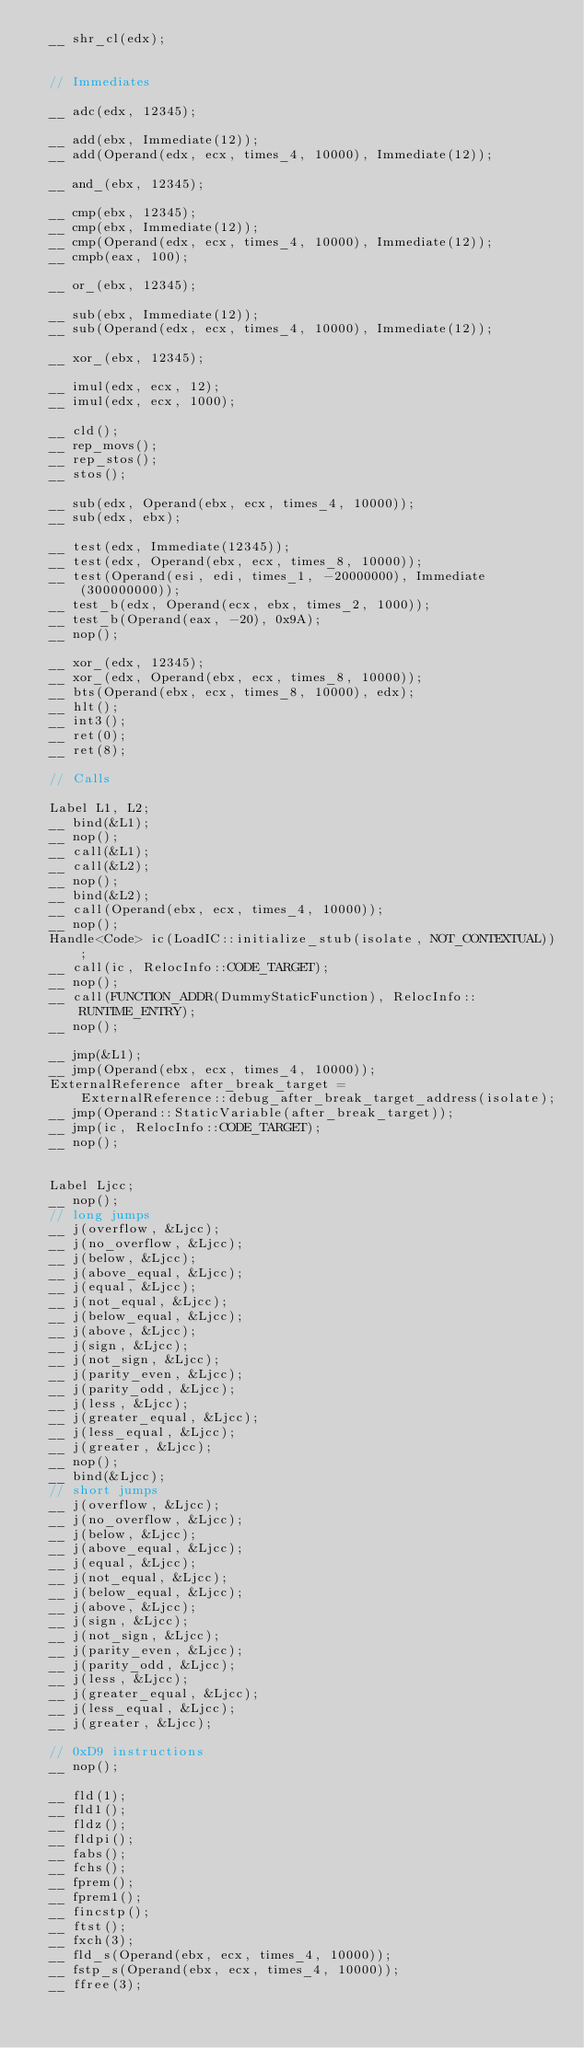<code> <loc_0><loc_0><loc_500><loc_500><_C++_>  __ shr_cl(edx);


  // Immediates

  __ adc(edx, 12345);

  __ add(ebx, Immediate(12));
  __ add(Operand(edx, ecx, times_4, 10000), Immediate(12));

  __ and_(ebx, 12345);

  __ cmp(ebx, 12345);
  __ cmp(ebx, Immediate(12));
  __ cmp(Operand(edx, ecx, times_4, 10000), Immediate(12));
  __ cmpb(eax, 100);

  __ or_(ebx, 12345);

  __ sub(ebx, Immediate(12));
  __ sub(Operand(edx, ecx, times_4, 10000), Immediate(12));

  __ xor_(ebx, 12345);

  __ imul(edx, ecx, 12);
  __ imul(edx, ecx, 1000);

  __ cld();
  __ rep_movs();
  __ rep_stos();
  __ stos();

  __ sub(edx, Operand(ebx, ecx, times_4, 10000));
  __ sub(edx, ebx);

  __ test(edx, Immediate(12345));
  __ test(edx, Operand(ebx, ecx, times_8, 10000));
  __ test(Operand(esi, edi, times_1, -20000000), Immediate(300000000));
  __ test_b(edx, Operand(ecx, ebx, times_2, 1000));
  __ test_b(Operand(eax, -20), 0x9A);
  __ nop();

  __ xor_(edx, 12345);
  __ xor_(edx, Operand(ebx, ecx, times_8, 10000));
  __ bts(Operand(ebx, ecx, times_8, 10000), edx);
  __ hlt();
  __ int3();
  __ ret(0);
  __ ret(8);

  // Calls

  Label L1, L2;
  __ bind(&L1);
  __ nop();
  __ call(&L1);
  __ call(&L2);
  __ nop();
  __ bind(&L2);
  __ call(Operand(ebx, ecx, times_4, 10000));
  __ nop();
  Handle<Code> ic(LoadIC::initialize_stub(isolate, NOT_CONTEXTUAL));
  __ call(ic, RelocInfo::CODE_TARGET);
  __ nop();
  __ call(FUNCTION_ADDR(DummyStaticFunction), RelocInfo::RUNTIME_ENTRY);
  __ nop();

  __ jmp(&L1);
  __ jmp(Operand(ebx, ecx, times_4, 10000));
  ExternalReference after_break_target =
      ExternalReference::debug_after_break_target_address(isolate);
  __ jmp(Operand::StaticVariable(after_break_target));
  __ jmp(ic, RelocInfo::CODE_TARGET);
  __ nop();


  Label Ljcc;
  __ nop();
  // long jumps
  __ j(overflow, &Ljcc);
  __ j(no_overflow, &Ljcc);
  __ j(below, &Ljcc);
  __ j(above_equal, &Ljcc);
  __ j(equal, &Ljcc);
  __ j(not_equal, &Ljcc);
  __ j(below_equal, &Ljcc);
  __ j(above, &Ljcc);
  __ j(sign, &Ljcc);
  __ j(not_sign, &Ljcc);
  __ j(parity_even, &Ljcc);
  __ j(parity_odd, &Ljcc);
  __ j(less, &Ljcc);
  __ j(greater_equal, &Ljcc);
  __ j(less_equal, &Ljcc);
  __ j(greater, &Ljcc);
  __ nop();
  __ bind(&Ljcc);
  // short jumps
  __ j(overflow, &Ljcc);
  __ j(no_overflow, &Ljcc);
  __ j(below, &Ljcc);
  __ j(above_equal, &Ljcc);
  __ j(equal, &Ljcc);
  __ j(not_equal, &Ljcc);
  __ j(below_equal, &Ljcc);
  __ j(above, &Ljcc);
  __ j(sign, &Ljcc);
  __ j(not_sign, &Ljcc);
  __ j(parity_even, &Ljcc);
  __ j(parity_odd, &Ljcc);
  __ j(less, &Ljcc);
  __ j(greater_equal, &Ljcc);
  __ j(less_equal, &Ljcc);
  __ j(greater, &Ljcc);

  // 0xD9 instructions
  __ nop();

  __ fld(1);
  __ fld1();
  __ fldz();
  __ fldpi();
  __ fabs();
  __ fchs();
  __ fprem();
  __ fprem1();
  __ fincstp();
  __ ftst();
  __ fxch(3);
  __ fld_s(Operand(ebx, ecx, times_4, 10000));
  __ fstp_s(Operand(ebx, ecx, times_4, 10000));
  __ ffree(3);</code> 